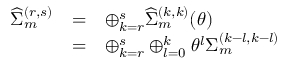Convert formula to latex. <formula><loc_0><loc_0><loc_500><loc_500>\begin{array} { l c l } { { { \widehat { \Sigma } } _ { m } ^ { ( r , s ) } } } & { = } & { { \oplus _ { k = r } ^ { s } { \widehat { \Sigma } } _ { m } ^ { ( k , k ) } ( \theta ) } } & { = } & { { \oplus _ { k = r } ^ { s } \oplus _ { l = 0 } ^ { k } { \theta } ^ { l } { \Sigma } _ { m } ^ { ( k - l , k - l ) } } } \end{array}</formula> 